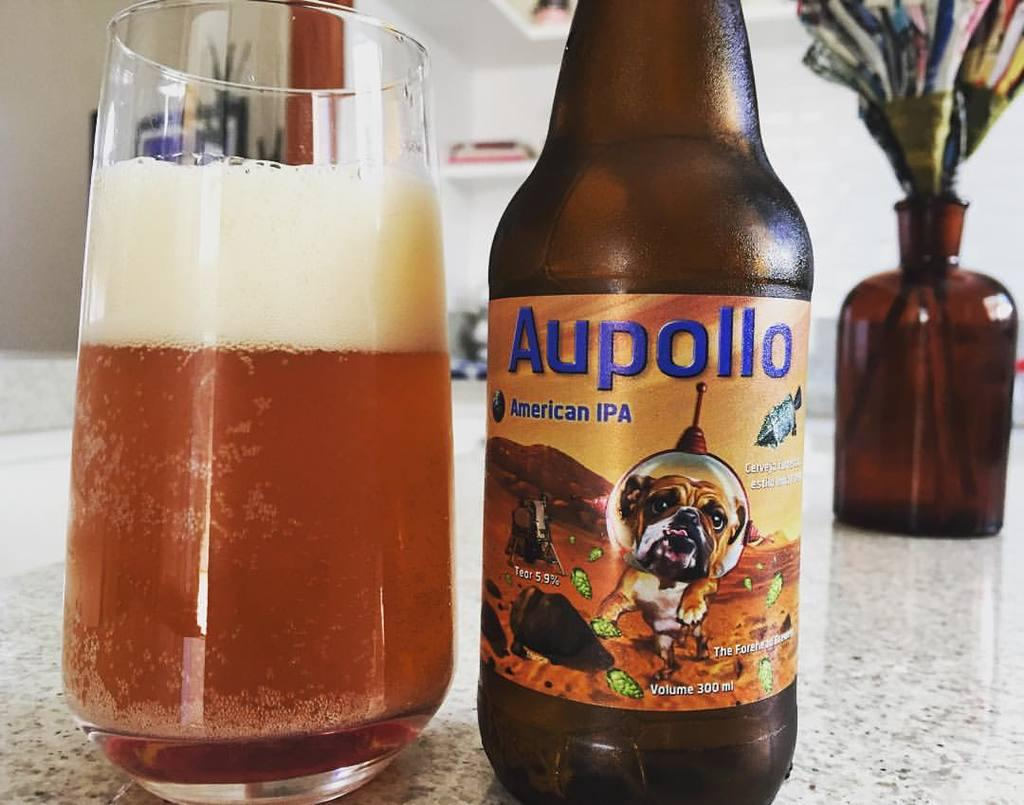<image>
Present a compact description of the photo's key features. A bottle of Aupollo beer next to a glass of beer. 